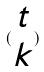<formula> <loc_0><loc_0><loc_500><loc_500>( \begin{matrix} t \\ k \end{matrix} )</formula> 